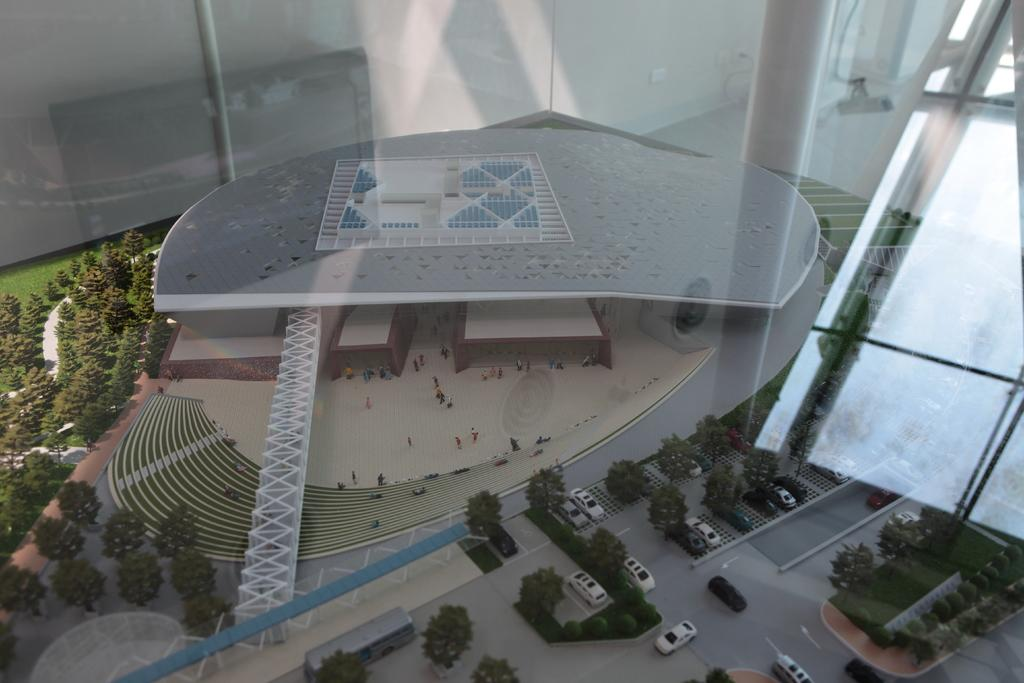What type of structure is in the image? There is a building in the image. What can be seen on the road in the image? There are cars on the road in the image. What type of vegetation is present in the image? There are trees in the image. What architectural feature is visible in the image? There are stairs in the image. Can you identify any living beings in the image? People are visible in the image. What structural elements support the building in the image? Pillars are present in the image. What type of bird can be seen singing an agreement with the people in the image? There is no bird present in the image, and no agreements are being made between the people. 